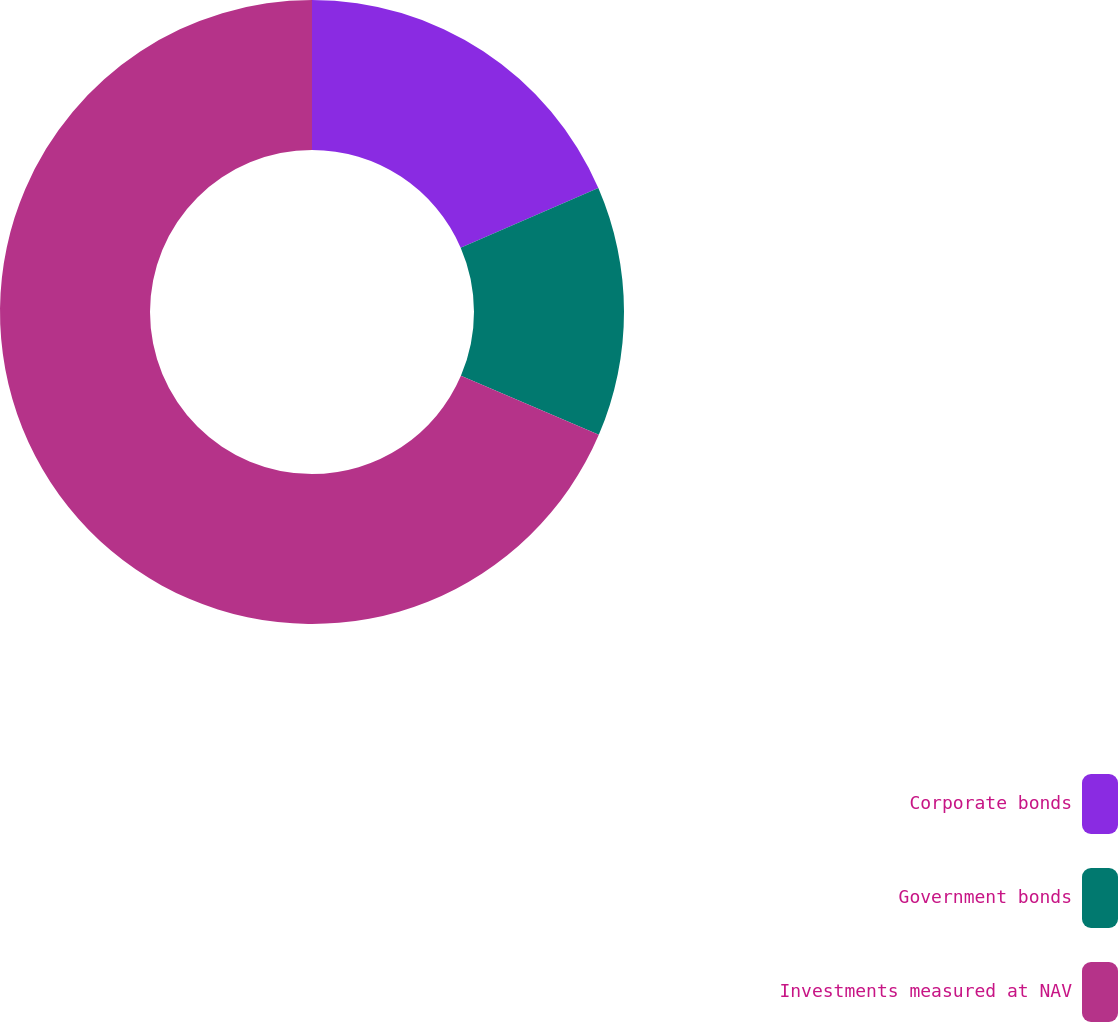Convert chart to OTSL. <chart><loc_0><loc_0><loc_500><loc_500><pie_chart><fcel>Corporate bonds<fcel>Government bonds<fcel>Investments measured at NAV<nl><fcel>18.5%<fcel>12.94%<fcel>68.56%<nl></chart> 